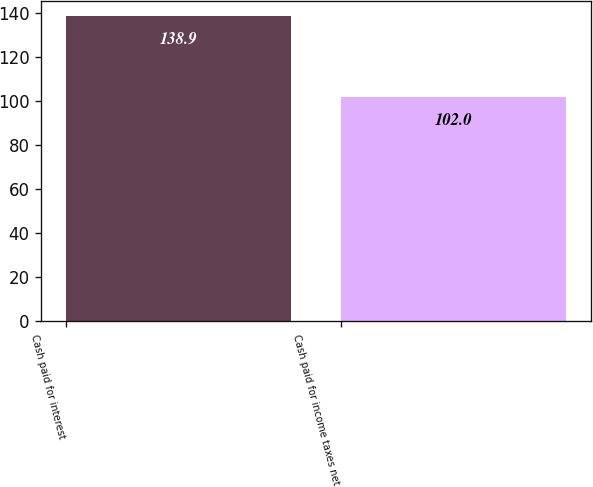Convert chart. <chart><loc_0><loc_0><loc_500><loc_500><bar_chart><fcel>Cash paid for interest<fcel>Cash paid for income taxes net<nl><fcel>138.9<fcel>102<nl></chart> 